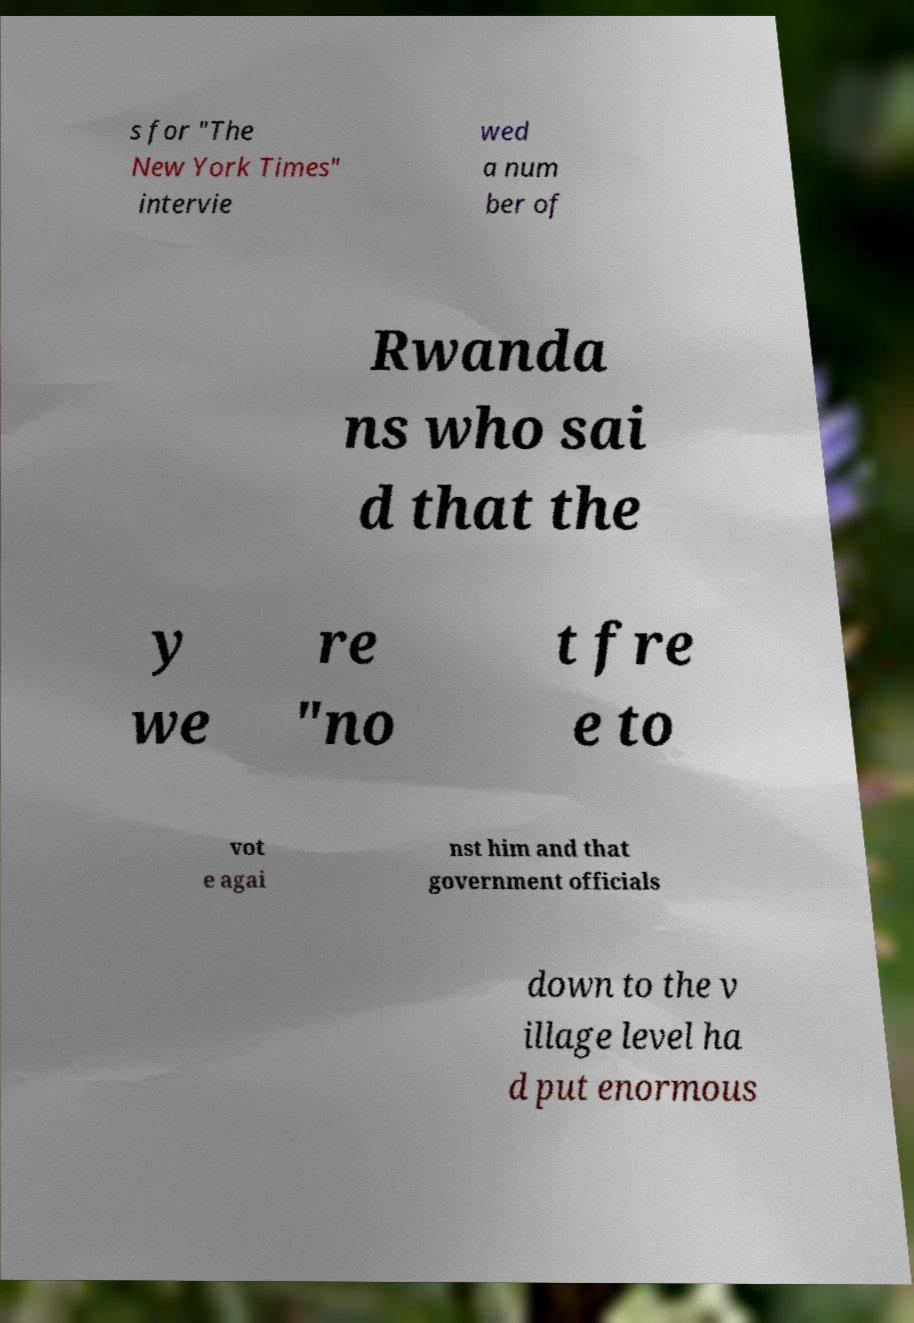I need the written content from this picture converted into text. Can you do that? s for "The New York Times" intervie wed a num ber of Rwanda ns who sai d that the y we re "no t fre e to vot e agai nst him and that government officials down to the v illage level ha d put enormous 